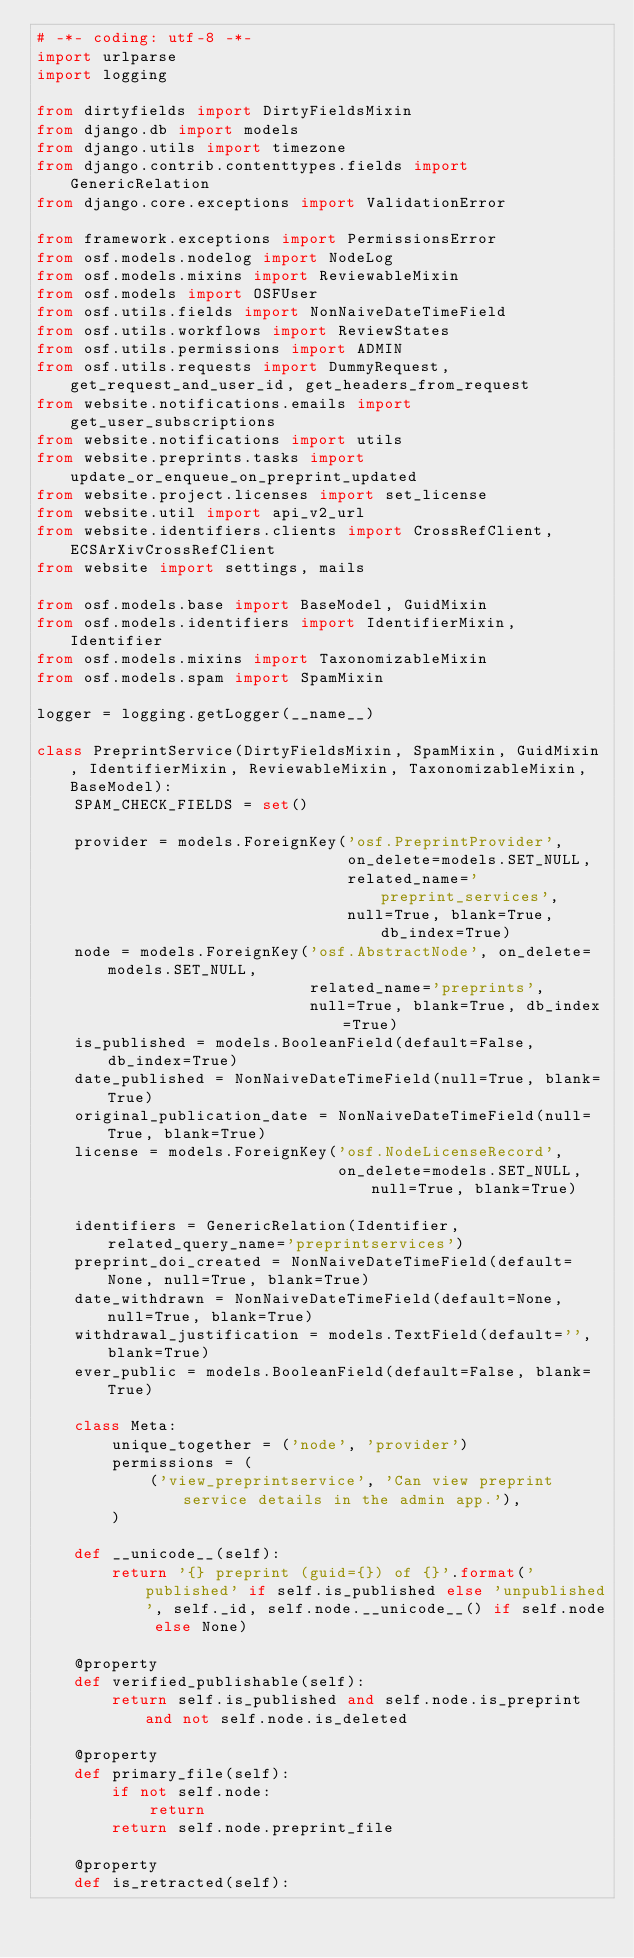<code> <loc_0><loc_0><loc_500><loc_500><_Python_># -*- coding: utf-8 -*-
import urlparse
import logging

from dirtyfields import DirtyFieldsMixin
from django.db import models
from django.utils import timezone
from django.contrib.contenttypes.fields import GenericRelation
from django.core.exceptions import ValidationError

from framework.exceptions import PermissionsError
from osf.models.nodelog import NodeLog
from osf.models.mixins import ReviewableMixin
from osf.models import OSFUser
from osf.utils.fields import NonNaiveDateTimeField
from osf.utils.workflows import ReviewStates
from osf.utils.permissions import ADMIN
from osf.utils.requests import DummyRequest, get_request_and_user_id, get_headers_from_request
from website.notifications.emails import get_user_subscriptions
from website.notifications import utils
from website.preprints.tasks import update_or_enqueue_on_preprint_updated
from website.project.licenses import set_license
from website.util import api_v2_url
from website.identifiers.clients import CrossRefClient, ECSArXivCrossRefClient
from website import settings, mails

from osf.models.base import BaseModel, GuidMixin
from osf.models.identifiers import IdentifierMixin, Identifier
from osf.models.mixins import TaxonomizableMixin
from osf.models.spam import SpamMixin

logger = logging.getLogger(__name__)

class PreprintService(DirtyFieldsMixin, SpamMixin, GuidMixin, IdentifierMixin, ReviewableMixin, TaxonomizableMixin, BaseModel):
    SPAM_CHECK_FIELDS = set()

    provider = models.ForeignKey('osf.PreprintProvider',
                                 on_delete=models.SET_NULL,
                                 related_name='preprint_services',
                                 null=True, blank=True, db_index=True)
    node = models.ForeignKey('osf.AbstractNode', on_delete=models.SET_NULL,
                             related_name='preprints',
                             null=True, blank=True, db_index=True)
    is_published = models.BooleanField(default=False, db_index=True)
    date_published = NonNaiveDateTimeField(null=True, blank=True)
    original_publication_date = NonNaiveDateTimeField(null=True, blank=True)
    license = models.ForeignKey('osf.NodeLicenseRecord',
                                on_delete=models.SET_NULL, null=True, blank=True)

    identifiers = GenericRelation(Identifier, related_query_name='preprintservices')
    preprint_doi_created = NonNaiveDateTimeField(default=None, null=True, blank=True)
    date_withdrawn = NonNaiveDateTimeField(default=None, null=True, blank=True)
    withdrawal_justification = models.TextField(default='', blank=True)
    ever_public = models.BooleanField(default=False, blank=True)

    class Meta:
        unique_together = ('node', 'provider')
        permissions = (
            ('view_preprintservice', 'Can view preprint service details in the admin app.'),
        )

    def __unicode__(self):
        return '{} preprint (guid={}) of {}'.format('published' if self.is_published else 'unpublished', self._id, self.node.__unicode__() if self.node else None)

    @property
    def verified_publishable(self):
        return self.is_published and self.node.is_preprint and not self.node.is_deleted

    @property
    def primary_file(self):
        if not self.node:
            return
        return self.node.preprint_file

    @property
    def is_retracted(self):</code> 